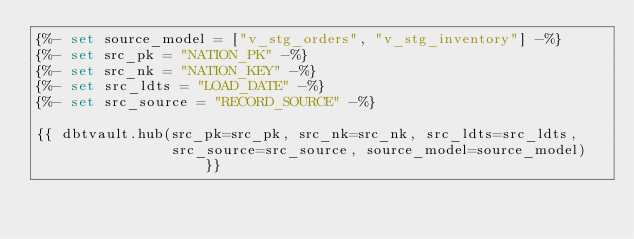Convert code to text. <code><loc_0><loc_0><loc_500><loc_500><_SQL_>{%- set source_model = ["v_stg_orders", "v_stg_inventory"] -%}
{%- set src_pk = "NATION_PK" -%}
{%- set src_nk = "NATION_KEY" -%}
{%- set src_ldts = "LOAD_DATE" -%}
{%- set src_source = "RECORD_SOURCE" -%}

{{ dbtvault.hub(src_pk=src_pk, src_nk=src_nk, src_ldts=src_ldts,
                src_source=src_source, source_model=source_model) }}</code> 